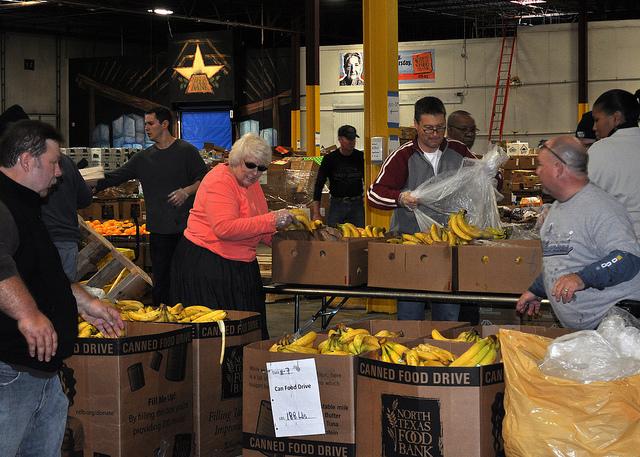Is this a wine show?
Short answer required. No. How many boxes of bananas are there?
Be succinct. 7. Is this market crowded?
Write a very short answer. Yes. Is the lady buying bananas?
Keep it brief. Yes. 